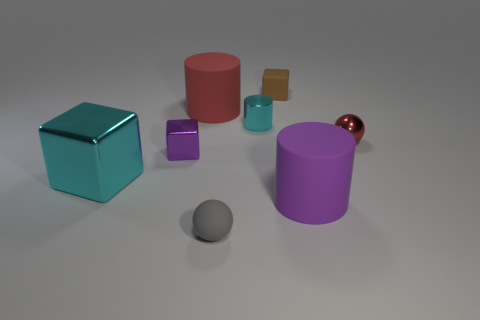Add 1 red metal things. How many objects exist? 9 Subtract all cylinders. How many objects are left? 5 Subtract all large green matte cylinders. Subtract all small shiny cubes. How many objects are left? 7 Add 4 red metallic things. How many red metallic things are left? 5 Add 3 tiny gray balls. How many tiny gray balls exist? 4 Subtract 0 brown cylinders. How many objects are left? 8 